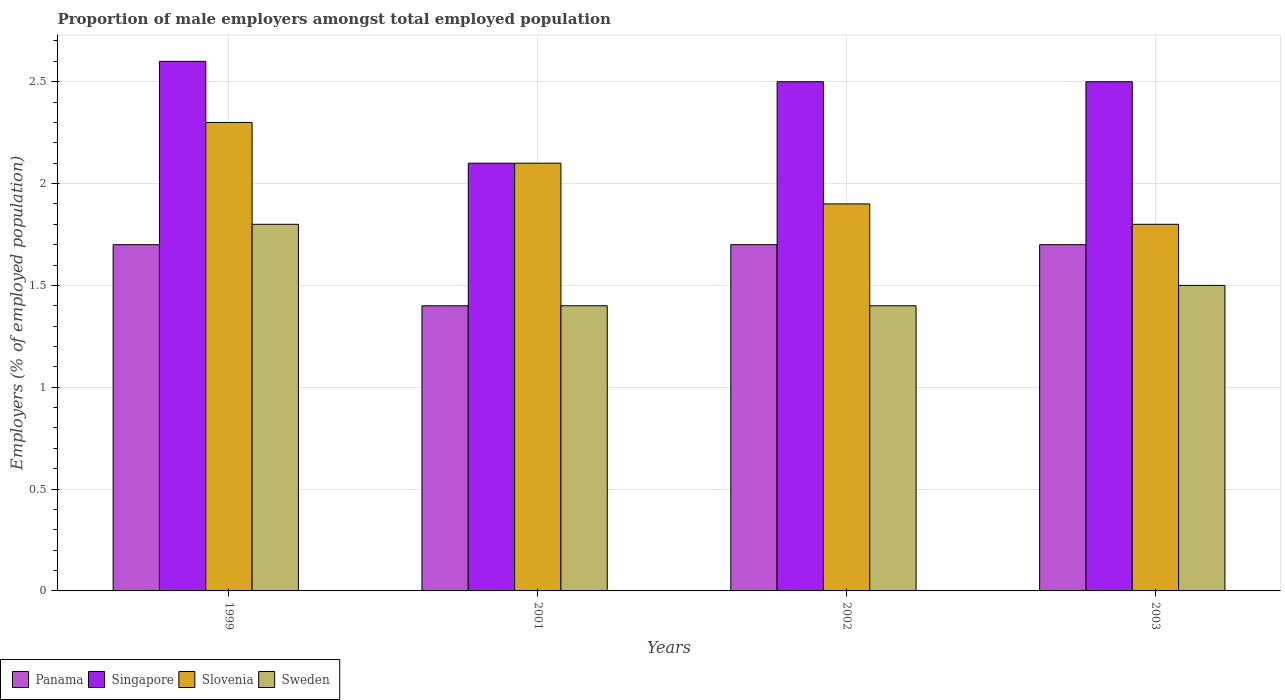How many groups of bars are there?
Provide a succinct answer. 4. How many bars are there on the 3rd tick from the left?
Your response must be concise. 4. In how many cases, is the number of bars for a given year not equal to the number of legend labels?
Provide a short and direct response. 0. Across all years, what is the maximum proportion of male employers in Sweden?
Keep it short and to the point. 1.8. Across all years, what is the minimum proportion of male employers in Panama?
Your answer should be compact. 1.4. In which year was the proportion of male employers in Panama maximum?
Provide a short and direct response. 1999. What is the total proportion of male employers in Panama in the graph?
Provide a short and direct response. 6.5. What is the difference between the proportion of male employers in Singapore in 2001 and that in 2002?
Make the answer very short. -0.4. What is the difference between the proportion of male employers in Singapore in 2002 and the proportion of male employers in Sweden in 1999?
Make the answer very short. 0.7. What is the average proportion of male employers in Sweden per year?
Your answer should be very brief. 1.52. What is the ratio of the proportion of male employers in Panama in 1999 to that in 2001?
Give a very brief answer. 1.21. Is the difference between the proportion of male employers in Singapore in 1999 and 2001 greater than the difference between the proportion of male employers in Slovenia in 1999 and 2001?
Provide a short and direct response. Yes. What is the difference between the highest and the second highest proportion of male employers in Panama?
Ensure brevity in your answer.  0. What is the difference between the highest and the lowest proportion of male employers in Sweden?
Make the answer very short. 0.4. Is it the case that in every year, the sum of the proportion of male employers in Slovenia and proportion of male employers in Singapore is greater than the sum of proportion of male employers in Sweden and proportion of male employers in Panama?
Offer a terse response. No. What does the 3rd bar from the left in 1999 represents?
Your response must be concise. Slovenia. What does the 2nd bar from the right in 2001 represents?
Your answer should be very brief. Slovenia. Is it the case that in every year, the sum of the proportion of male employers in Slovenia and proportion of male employers in Sweden is greater than the proportion of male employers in Singapore?
Offer a very short reply. Yes. How many bars are there?
Give a very brief answer. 16. Are all the bars in the graph horizontal?
Provide a succinct answer. No. How many years are there in the graph?
Keep it short and to the point. 4. Are the values on the major ticks of Y-axis written in scientific E-notation?
Give a very brief answer. No. Where does the legend appear in the graph?
Your response must be concise. Bottom left. How many legend labels are there?
Give a very brief answer. 4. What is the title of the graph?
Give a very brief answer. Proportion of male employers amongst total employed population. What is the label or title of the X-axis?
Offer a very short reply. Years. What is the label or title of the Y-axis?
Provide a succinct answer. Employers (% of employed population). What is the Employers (% of employed population) in Panama in 1999?
Offer a very short reply. 1.7. What is the Employers (% of employed population) of Singapore in 1999?
Give a very brief answer. 2.6. What is the Employers (% of employed population) of Slovenia in 1999?
Ensure brevity in your answer.  2.3. What is the Employers (% of employed population) of Sweden in 1999?
Offer a very short reply. 1.8. What is the Employers (% of employed population) in Panama in 2001?
Offer a terse response. 1.4. What is the Employers (% of employed population) in Singapore in 2001?
Give a very brief answer. 2.1. What is the Employers (% of employed population) in Slovenia in 2001?
Offer a terse response. 2.1. What is the Employers (% of employed population) of Sweden in 2001?
Ensure brevity in your answer.  1.4. What is the Employers (% of employed population) of Panama in 2002?
Give a very brief answer. 1.7. What is the Employers (% of employed population) of Slovenia in 2002?
Your answer should be compact. 1.9. What is the Employers (% of employed population) of Sweden in 2002?
Provide a succinct answer. 1.4. What is the Employers (% of employed population) of Panama in 2003?
Offer a terse response. 1.7. What is the Employers (% of employed population) in Singapore in 2003?
Your answer should be compact. 2.5. What is the Employers (% of employed population) in Slovenia in 2003?
Your response must be concise. 1.8. Across all years, what is the maximum Employers (% of employed population) in Panama?
Keep it short and to the point. 1.7. Across all years, what is the maximum Employers (% of employed population) in Singapore?
Give a very brief answer. 2.6. Across all years, what is the maximum Employers (% of employed population) of Slovenia?
Give a very brief answer. 2.3. Across all years, what is the maximum Employers (% of employed population) in Sweden?
Offer a terse response. 1.8. Across all years, what is the minimum Employers (% of employed population) of Panama?
Provide a short and direct response. 1.4. Across all years, what is the minimum Employers (% of employed population) in Singapore?
Provide a succinct answer. 2.1. Across all years, what is the minimum Employers (% of employed population) in Slovenia?
Your answer should be compact. 1.8. Across all years, what is the minimum Employers (% of employed population) in Sweden?
Give a very brief answer. 1.4. What is the total Employers (% of employed population) in Panama in the graph?
Provide a short and direct response. 6.5. What is the total Employers (% of employed population) in Singapore in the graph?
Make the answer very short. 9.7. What is the total Employers (% of employed population) in Slovenia in the graph?
Ensure brevity in your answer.  8.1. What is the difference between the Employers (% of employed population) in Slovenia in 1999 and that in 2001?
Provide a short and direct response. 0.2. What is the difference between the Employers (% of employed population) of Sweden in 1999 and that in 2001?
Offer a very short reply. 0.4. What is the difference between the Employers (% of employed population) of Singapore in 1999 and that in 2002?
Your answer should be very brief. 0.1. What is the difference between the Employers (% of employed population) of Panama in 1999 and that in 2003?
Offer a terse response. 0. What is the difference between the Employers (% of employed population) in Slovenia in 1999 and that in 2003?
Offer a very short reply. 0.5. What is the difference between the Employers (% of employed population) of Singapore in 2001 and that in 2002?
Your response must be concise. -0.4. What is the difference between the Employers (% of employed population) in Slovenia in 2001 and that in 2002?
Your answer should be compact. 0.2. What is the difference between the Employers (% of employed population) of Sweden in 2001 and that in 2002?
Keep it short and to the point. 0. What is the difference between the Employers (% of employed population) in Panama in 2001 and that in 2003?
Offer a terse response. -0.3. What is the difference between the Employers (% of employed population) of Singapore in 2001 and that in 2003?
Provide a short and direct response. -0.4. What is the difference between the Employers (% of employed population) in Slovenia in 2001 and that in 2003?
Your answer should be very brief. 0.3. What is the difference between the Employers (% of employed population) of Singapore in 2002 and that in 2003?
Your answer should be very brief. 0. What is the difference between the Employers (% of employed population) of Panama in 1999 and the Employers (% of employed population) of Singapore in 2001?
Provide a short and direct response. -0.4. What is the difference between the Employers (% of employed population) in Panama in 1999 and the Employers (% of employed population) in Sweden in 2001?
Provide a short and direct response. 0.3. What is the difference between the Employers (% of employed population) of Singapore in 1999 and the Employers (% of employed population) of Slovenia in 2001?
Keep it short and to the point. 0.5. What is the difference between the Employers (% of employed population) in Singapore in 1999 and the Employers (% of employed population) in Sweden in 2001?
Keep it short and to the point. 1.2. What is the difference between the Employers (% of employed population) of Panama in 1999 and the Employers (% of employed population) of Singapore in 2002?
Keep it short and to the point. -0.8. What is the difference between the Employers (% of employed population) in Singapore in 1999 and the Employers (% of employed population) in Sweden in 2002?
Your response must be concise. 1.2. What is the difference between the Employers (% of employed population) of Panama in 1999 and the Employers (% of employed population) of Slovenia in 2003?
Your answer should be compact. -0.1. What is the difference between the Employers (% of employed population) in Singapore in 1999 and the Employers (% of employed population) in Sweden in 2003?
Provide a succinct answer. 1.1. What is the difference between the Employers (% of employed population) in Panama in 2001 and the Employers (% of employed population) in Sweden in 2002?
Offer a terse response. 0. What is the difference between the Employers (% of employed population) of Panama in 2001 and the Employers (% of employed population) of Slovenia in 2003?
Your response must be concise. -0.4. What is the difference between the Employers (% of employed population) in Panama in 2001 and the Employers (% of employed population) in Sweden in 2003?
Your answer should be very brief. -0.1. What is the difference between the Employers (% of employed population) in Panama in 2002 and the Employers (% of employed population) in Singapore in 2003?
Keep it short and to the point. -0.8. What is the difference between the Employers (% of employed population) of Singapore in 2002 and the Employers (% of employed population) of Slovenia in 2003?
Your answer should be compact. 0.7. What is the average Employers (% of employed population) in Panama per year?
Keep it short and to the point. 1.62. What is the average Employers (% of employed population) of Singapore per year?
Give a very brief answer. 2.42. What is the average Employers (% of employed population) in Slovenia per year?
Make the answer very short. 2.02. What is the average Employers (% of employed population) of Sweden per year?
Make the answer very short. 1.52. In the year 1999, what is the difference between the Employers (% of employed population) in Panama and Employers (% of employed population) in Singapore?
Ensure brevity in your answer.  -0.9. In the year 1999, what is the difference between the Employers (% of employed population) of Panama and Employers (% of employed population) of Sweden?
Make the answer very short. -0.1. In the year 1999, what is the difference between the Employers (% of employed population) in Singapore and Employers (% of employed population) in Sweden?
Give a very brief answer. 0.8. In the year 1999, what is the difference between the Employers (% of employed population) in Slovenia and Employers (% of employed population) in Sweden?
Your answer should be very brief. 0.5. In the year 2001, what is the difference between the Employers (% of employed population) in Panama and Employers (% of employed population) in Singapore?
Your answer should be compact. -0.7. In the year 2001, what is the difference between the Employers (% of employed population) of Panama and Employers (% of employed population) of Slovenia?
Offer a very short reply. -0.7. In the year 2001, what is the difference between the Employers (% of employed population) in Singapore and Employers (% of employed population) in Slovenia?
Provide a short and direct response. 0. In the year 2001, what is the difference between the Employers (% of employed population) in Singapore and Employers (% of employed population) in Sweden?
Ensure brevity in your answer.  0.7. In the year 2001, what is the difference between the Employers (% of employed population) in Slovenia and Employers (% of employed population) in Sweden?
Your answer should be compact. 0.7. In the year 2002, what is the difference between the Employers (% of employed population) in Panama and Employers (% of employed population) in Singapore?
Provide a short and direct response. -0.8. In the year 2002, what is the difference between the Employers (% of employed population) of Singapore and Employers (% of employed population) of Slovenia?
Keep it short and to the point. 0.6. In the year 2002, what is the difference between the Employers (% of employed population) of Singapore and Employers (% of employed population) of Sweden?
Provide a short and direct response. 1.1. In the year 2002, what is the difference between the Employers (% of employed population) of Slovenia and Employers (% of employed population) of Sweden?
Offer a terse response. 0.5. In the year 2003, what is the difference between the Employers (% of employed population) in Panama and Employers (% of employed population) in Singapore?
Offer a very short reply. -0.8. In the year 2003, what is the difference between the Employers (% of employed population) of Panama and Employers (% of employed population) of Sweden?
Your answer should be very brief. 0.2. In the year 2003, what is the difference between the Employers (% of employed population) in Singapore and Employers (% of employed population) in Slovenia?
Ensure brevity in your answer.  0.7. In the year 2003, what is the difference between the Employers (% of employed population) in Singapore and Employers (% of employed population) in Sweden?
Keep it short and to the point. 1. In the year 2003, what is the difference between the Employers (% of employed population) in Slovenia and Employers (% of employed population) in Sweden?
Ensure brevity in your answer.  0.3. What is the ratio of the Employers (% of employed population) in Panama in 1999 to that in 2001?
Ensure brevity in your answer.  1.21. What is the ratio of the Employers (% of employed population) of Singapore in 1999 to that in 2001?
Provide a short and direct response. 1.24. What is the ratio of the Employers (% of employed population) in Slovenia in 1999 to that in 2001?
Give a very brief answer. 1.1. What is the ratio of the Employers (% of employed population) in Sweden in 1999 to that in 2001?
Make the answer very short. 1.29. What is the ratio of the Employers (% of employed population) of Panama in 1999 to that in 2002?
Your answer should be compact. 1. What is the ratio of the Employers (% of employed population) in Slovenia in 1999 to that in 2002?
Give a very brief answer. 1.21. What is the ratio of the Employers (% of employed population) of Panama in 1999 to that in 2003?
Offer a terse response. 1. What is the ratio of the Employers (% of employed population) of Singapore in 1999 to that in 2003?
Make the answer very short. 1.04. What is the ratio of the Employers (% of employed population) of Slovenia in 1999 to that in 2003?
Offer a very short reply. 1.28. What is the ratio of the Employers (% of employed population) in Sweden in 1999 to that in 2003?
Your answer should be very brief. 1.2. What is the ratio of the Employers (% of employed population) of Panama in 2001 to that in 2002?
Keep it short and to the point. 0.82. What is the ratio of the Employers (% of employed population) in Singapore in 2001 to that in 2002?
Your answer should be compact. 0.84. What is the ratio of the Employers (% of employed population) of Slovenia in 2001 to that in 2002?
Offer a terse response. 1.11. What is the ratio of the Employers (% of employed population) in Panama in 2001 to that in 2003?
Give a very brief answer. 0.82. What is the ratio of the Employers (% of employed population) in Singapore in 2001 to that in 2003?
Keep it short and to the point. 0.84. What is the ratio of the Employers (% of employed population) in Sweden in 2001 to that in 2003?
Keep it short and to the point. 0.93. What is the ratio of the Employers (% of employed population) of Panama in 2002 to that in 2003?
Your answer should be very brief. 1. What is the ratio of the Employers (% of employed population) in Singapore in 2002 to that in 2003?
Your answer should be compact. 1. What is the ratio of the Employers (% of employed population) of Slovenia in 2002 to that in 2003?
Ensure brevity in your answer.  1.06. What is the difference between the highest and the second highest Employers (% of employed population) in Singapore?
Provide a succinct answer. 0.1. What is the difference between the highest and the second highest Employers (% of employed population) of Sweden?
Provide a succinct answer. 0.3. What is the difference between the highest and the lowest Employers (% of employed population) of Singapore?
Provide a succinct answer. 0.5. 